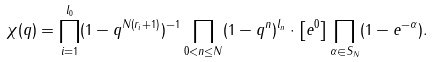Convert formula to latex. <formula><loc_0><loc_0><loc_500><loc_500>\chi ( q ) = \prod _ { i = 1 } ^ { l _ { 0 } } ( 1 - q ^ { N ( r _ { i } + 1 ) } ) ^ { - 1 } \prod _ { 0 < n \leq N } ( 1 - q ^ { n } ) ^ { l _ { n } } \cdot \left [ e ^ { 0 } \right ] \prod _ { \alpha \in S _ { N } } ( 1 - e ^ { - \alpha } ) .</formula> 